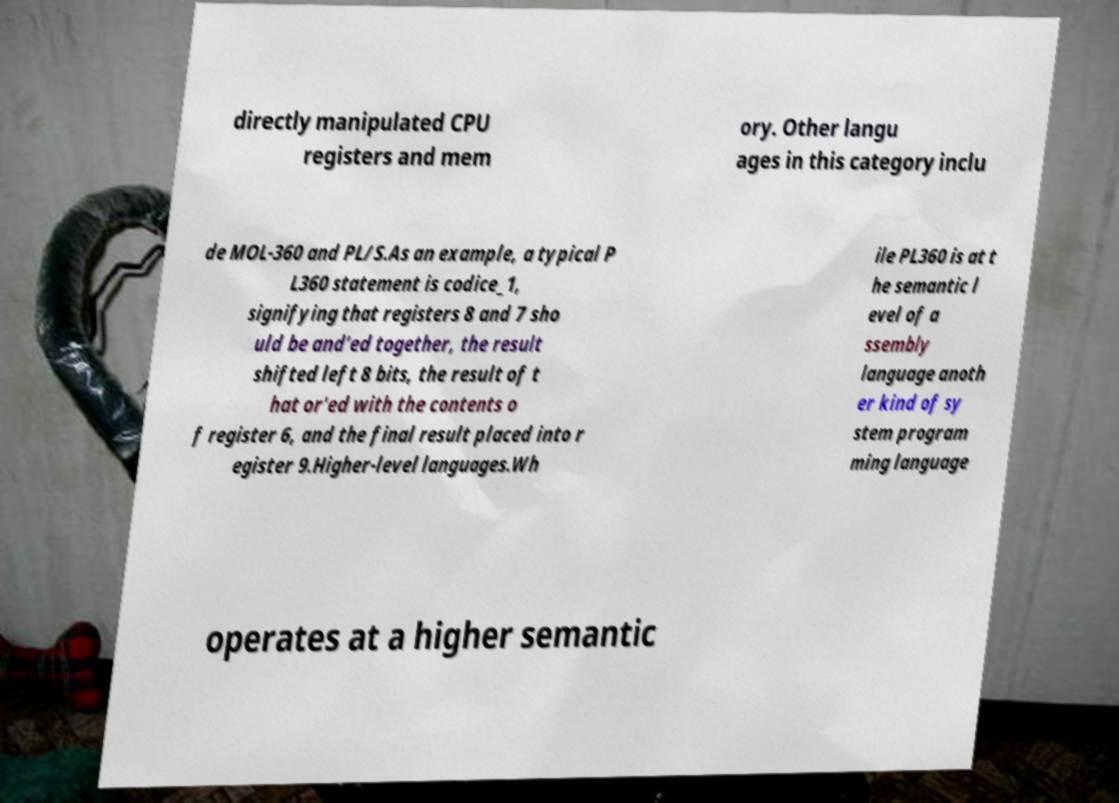For documentation purposes, I need the text within this image transcribed. Could you provide that? directly manipulated CPU registers and mem ory. Other langu ages in this category inclu de MOL-360 and PL/S.As an example, a typical P L360 statement is codice_1, signifying that registers 8 and 7 sho uld be and'ed together, the result shifted left 8 bits, the result of t hat or'ed with the contents o f register 6, and the final result placed into r egister 9.Higher-level languages.Wh ile PL360 is at t he semantic l evel of a ssembly language anoth er kind of sy stem program ming language operates at a higher semantic 